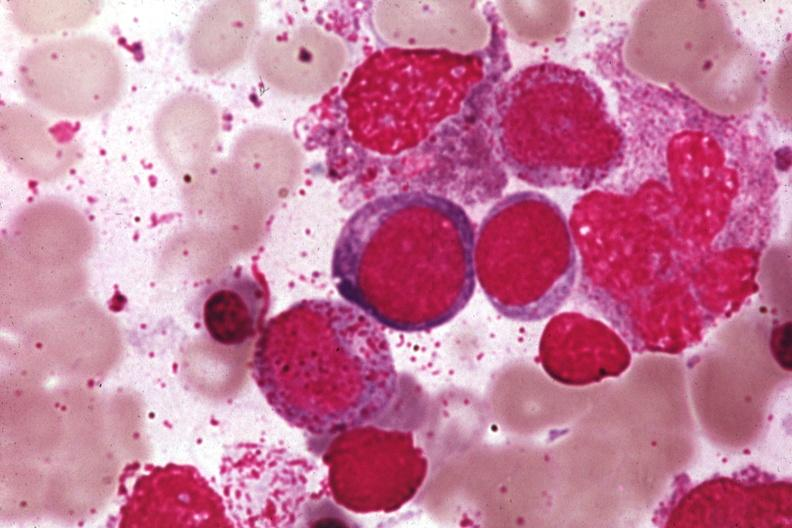what is present?
Answer the question using a single word or phrase. Bone marrow 